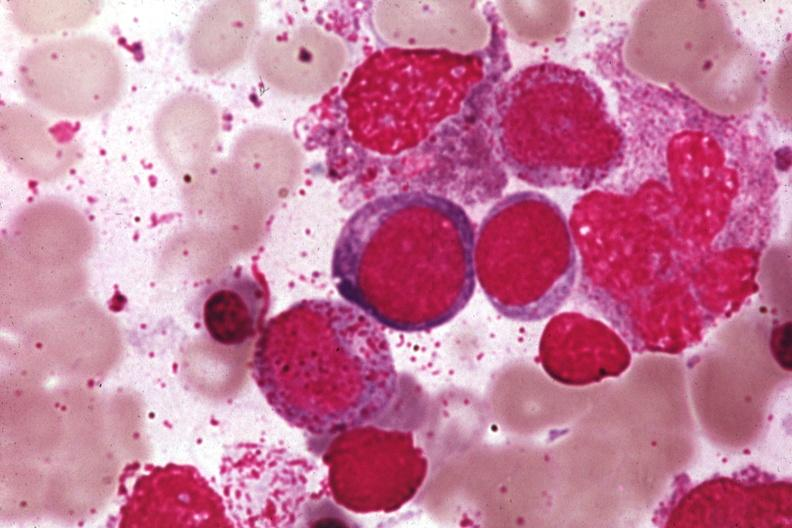what is present?
Answer the question using a single word or phrase. Bone marrow 